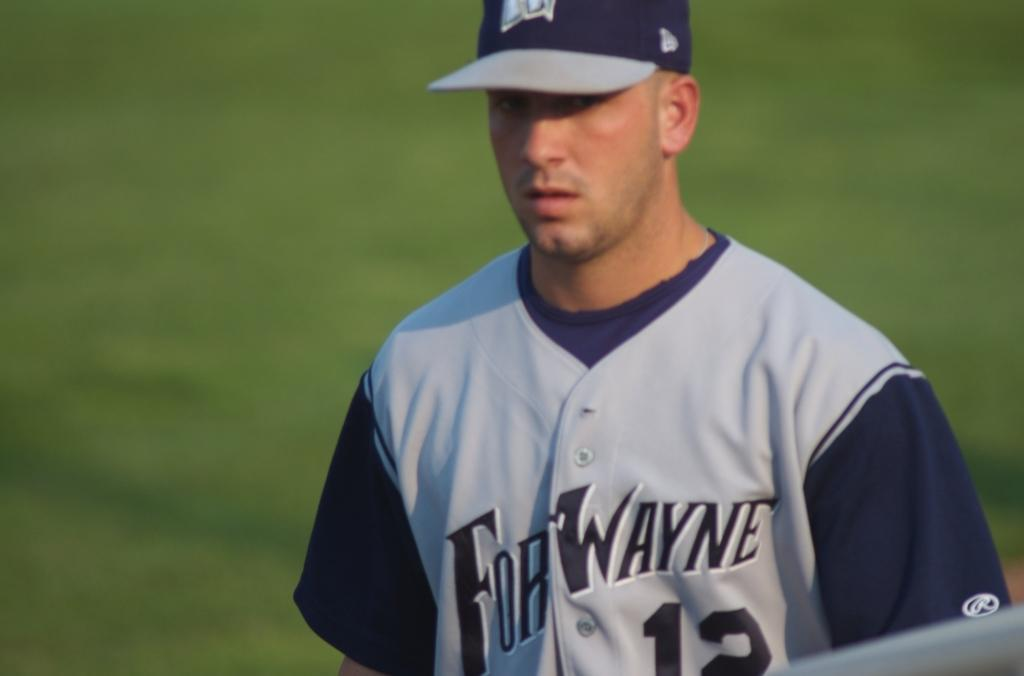<image>
Create a compact narrative representing the image presented. A Fort Wayne baseball player stands on a grassy field. 